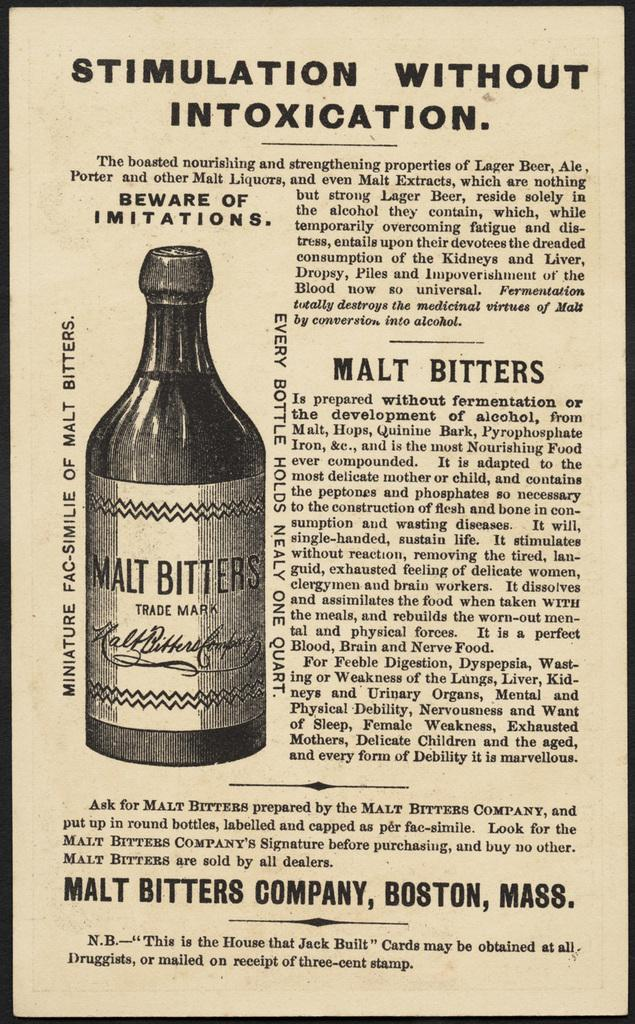<image>
Render a clear and concise summary of the photo. An advert for Malt bitters that has the headline that reads Stimulation without intoxication. 